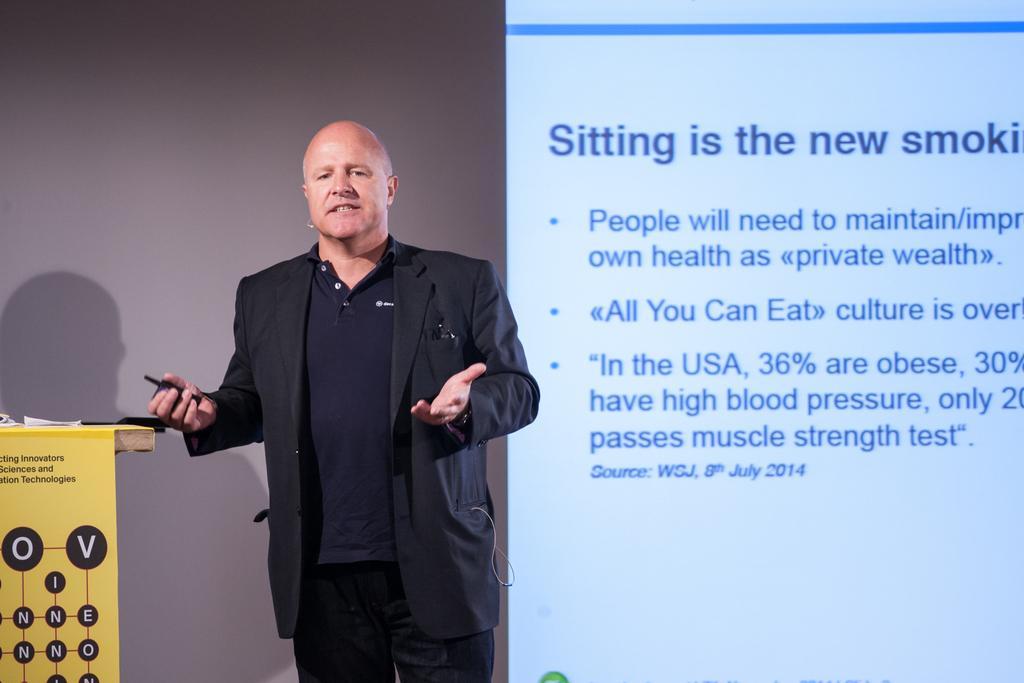Please provide a concise description of this image. In the image we can see there is a person standing near the podium and he is wearing jacket. He is holding mobile phone in his hand and behind there is a projector screen and matter is written on it. 